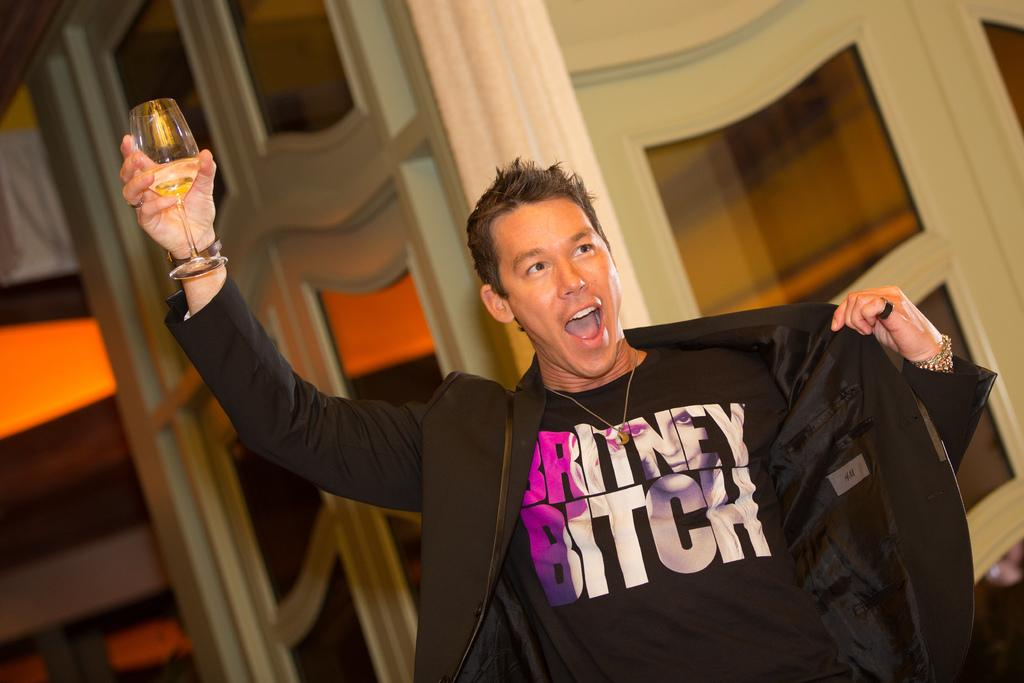What is the main subject of the image? The main subject of the image is a man. What is the man holding in his right hand? The man is holding a glass of wine in his right hand. What expression does the man have on his face? The man is smiling. What type of wilderness can be seen in the background of the image? There is no wilderness visible in the image; it only features a man holding a glass of wine. What is the man's purpose for holding the glass of wine in the image? There is no information provided about the man's purpose for holding the glass of wine in the image. 